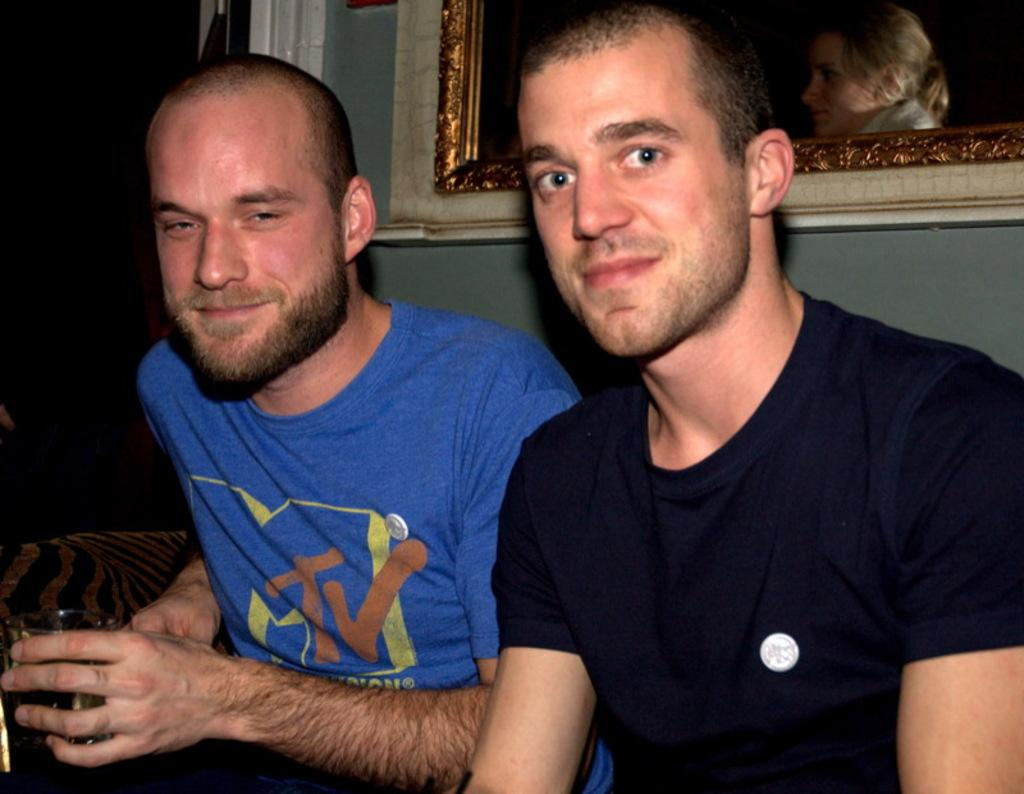How many people are sitting on the sofa in the image? There are two people sitting on the sofa in the image. What is behind the sofa in the image? There is a wall behind the sofa in the image. What can be seen on the wall behind the sofa? There is a photo frame on the wall behind the sofa. Where is the calculator located in the image? There is no calculator present in the image. What type of nest can be seen on the sofa? There is no nest present in the image. 